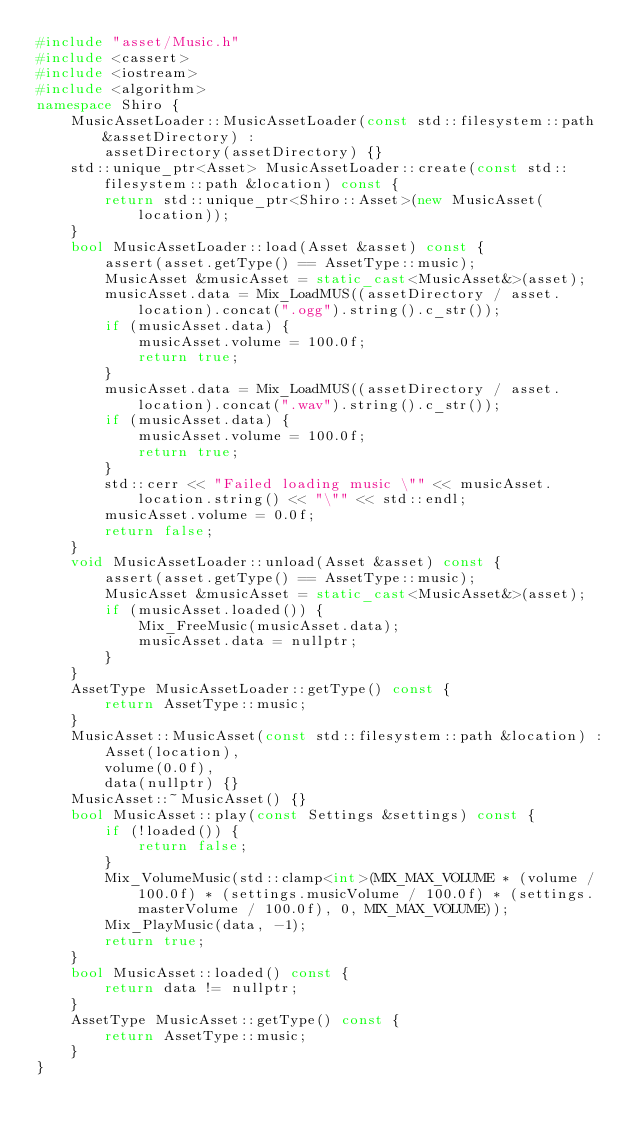Convert code to text. <code><loc_0><loc_0><loc_500><loc_500><_C++_>#include "asset/Music.h"
#include <cassert>
#include <iostream>
#include <algorithm>
namespace Shiro {
    MusicAssetLoader::MusicAssetLoader(const std::filesystem::path &assetDirectory) :
        assetDirectory(assetDirectory) {}
    std::unique_ptr<Asset> MusicAssetLoader::create(const std::filesystem::path &location) const {
        return std::unique_ptr<Shiro::Asset>(new MusicAsset(location));
    }
    bool MusicAssetLoader::load(Asset &asset) const {
        assert(asset.getType() == AssetType::music);
        MusicAsset &musicAsset = static_cast<MusicAsset&>(asset);
        musicAsset.data = Mix_LoadMUS((assetDirectory / asset.location).concat(".ogg").string().c_str());
        if (musicAsset.data) {
            musicAsset.volume = 100.0f;
            return true;
        }
        musicAsset.data = Mix_LoadMUS((assetDirectory / asset.location).concat(".wav").string().c_str());
        if (musicAsset.data) {
            musicAsset.volume = 100.0f;
            return true;
        }
        std::cerr << "Failed loading music \"" << musicAsset.location.string() << "\"" << std::endl;
        musicAsset.volume = 0.0f;
        return false;
    }
    void MusicAssetLoader::unload(Asset &asset) const {
        assert(asset.getType() == AssetType::music);
        MusicAsset &musicAsset = static_cast<MusicAsset&>(asset);
        if (musicAsset.loaded()) {
            Mix_FreeMusic(musicAsset.data);
            musicAsset.data = nullptr;
        }
    }
    AssetType MusicAssetLoader::getType() const {
        return AssetType::music;
    }
    MusicAsset::MusicAsset(const std::filesystem::path &location) :
        Asset(location),
        volume(0.0f),
        data(nullptr) {}
    MusicAsset::~MusicAsset() {}
    bool MusicAsset::play(const Settings &settings) const {
        if (!loaded()) {
            return false;
        }
        Mix_VolumeMusic(std::clamp<int>(MIX_MAX_VOLUME * (volume / 100.0f) * (settings.musicVolume / 100.0f) * (settings.masterVolume / 100.0f), 0, MIX_MAX_VOLUME));
        Mix_PlayMusic(data, -1);
        return true;
    }
    bool MusicAsset::loaded() const {
        return data != nullptr;
    }
    AssetType MusicAsset::getType() const {
        return AssetType::music;
    }
}</code> 